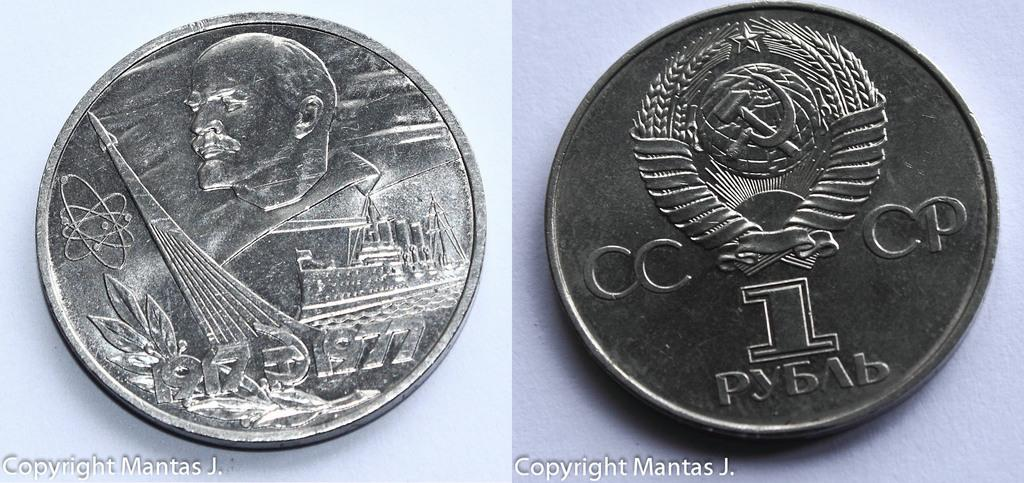Provide a one-sentence caption for the provided image. Front and back of a silver 1 rouble Russian coin. 